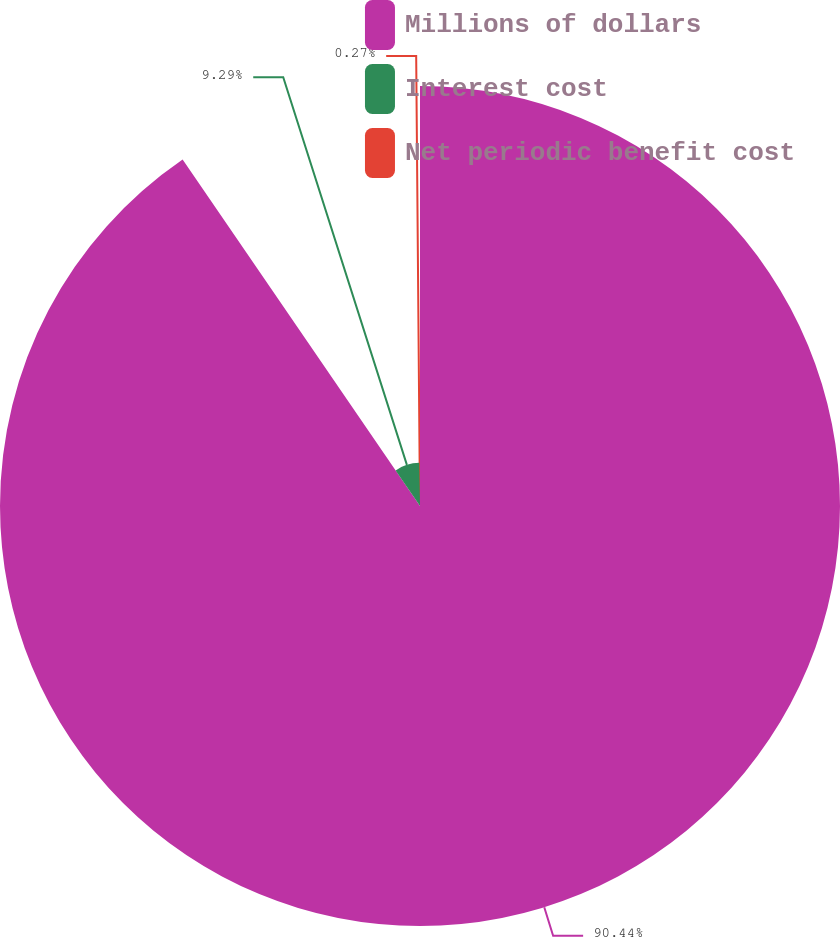Convert chart. <chart><loc_0><loc_0><loc_500><loc_500><pie_chart><fcel>Millions of dollars<fcel>Interest cost<fcel>Net periodic benefit cost<nl><fcel>90.44%<fcel>9.29%<fcel>0.27%<nl></chart> 